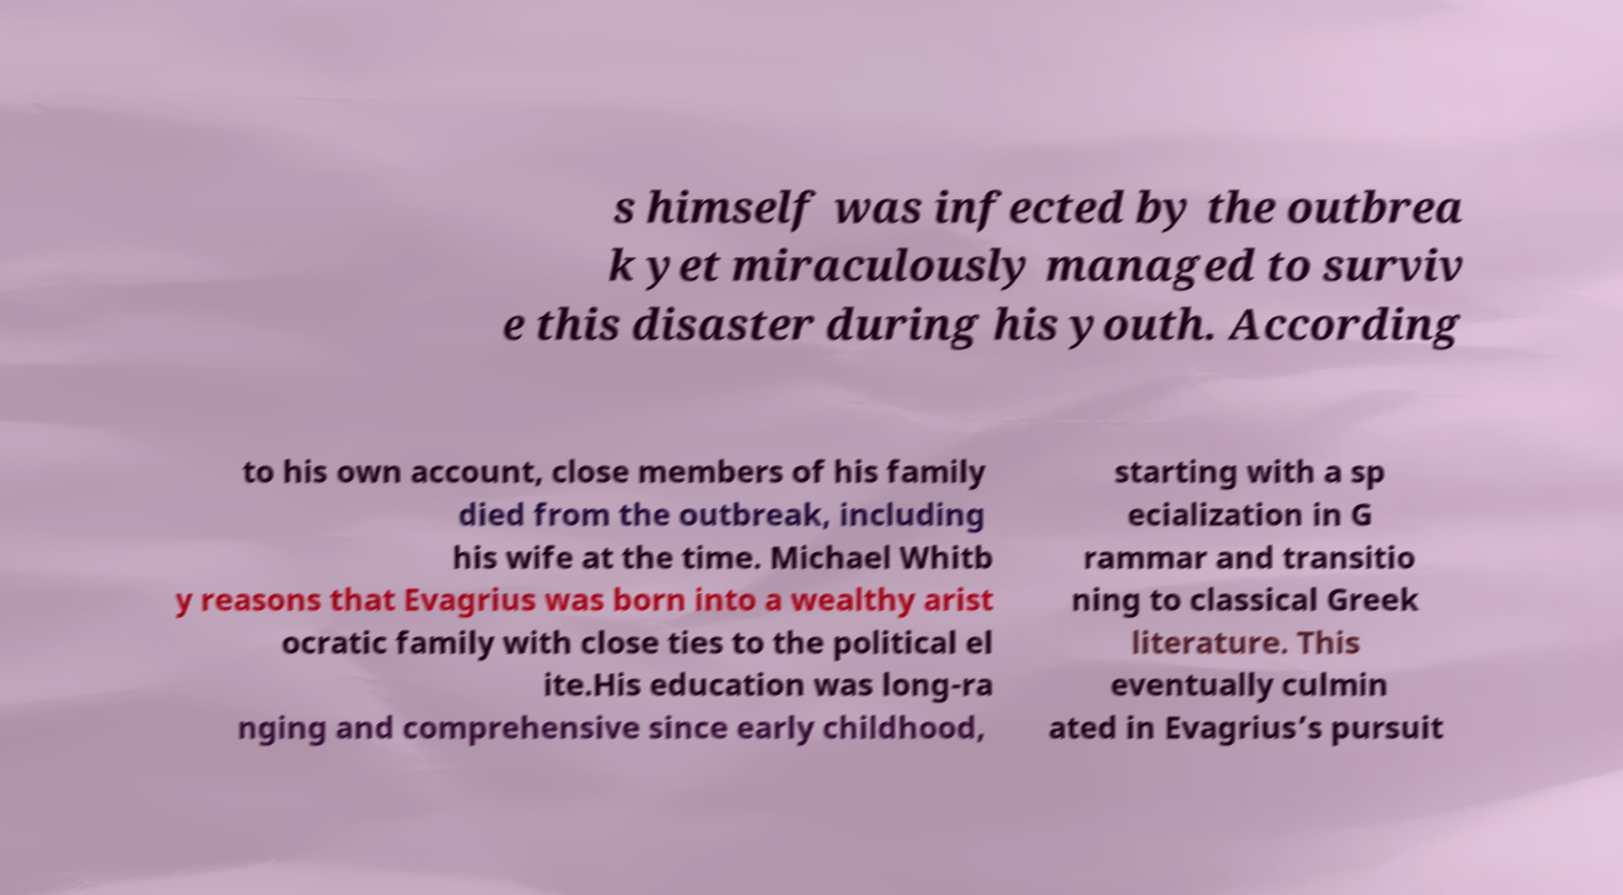For documentation purposes, I need the text within this image transcribed. Could you provide that? s himself was infected by the outbrea k yet miraculously managed to surviv e this disaster during his youth. According to his own account, close members of his family died from the outbreak, including his wife at the time. Michael Whitb y reasons that Evagrius was born into a wealthy arist ocratic family with close ties to the political el ite.His education was long-ra nging and comprehensive since early childhood, starting with a sp ecialization in G rammar and transitio ning to classical Greek literature. This eventually culmin ated in Evagrius’s pursuit 